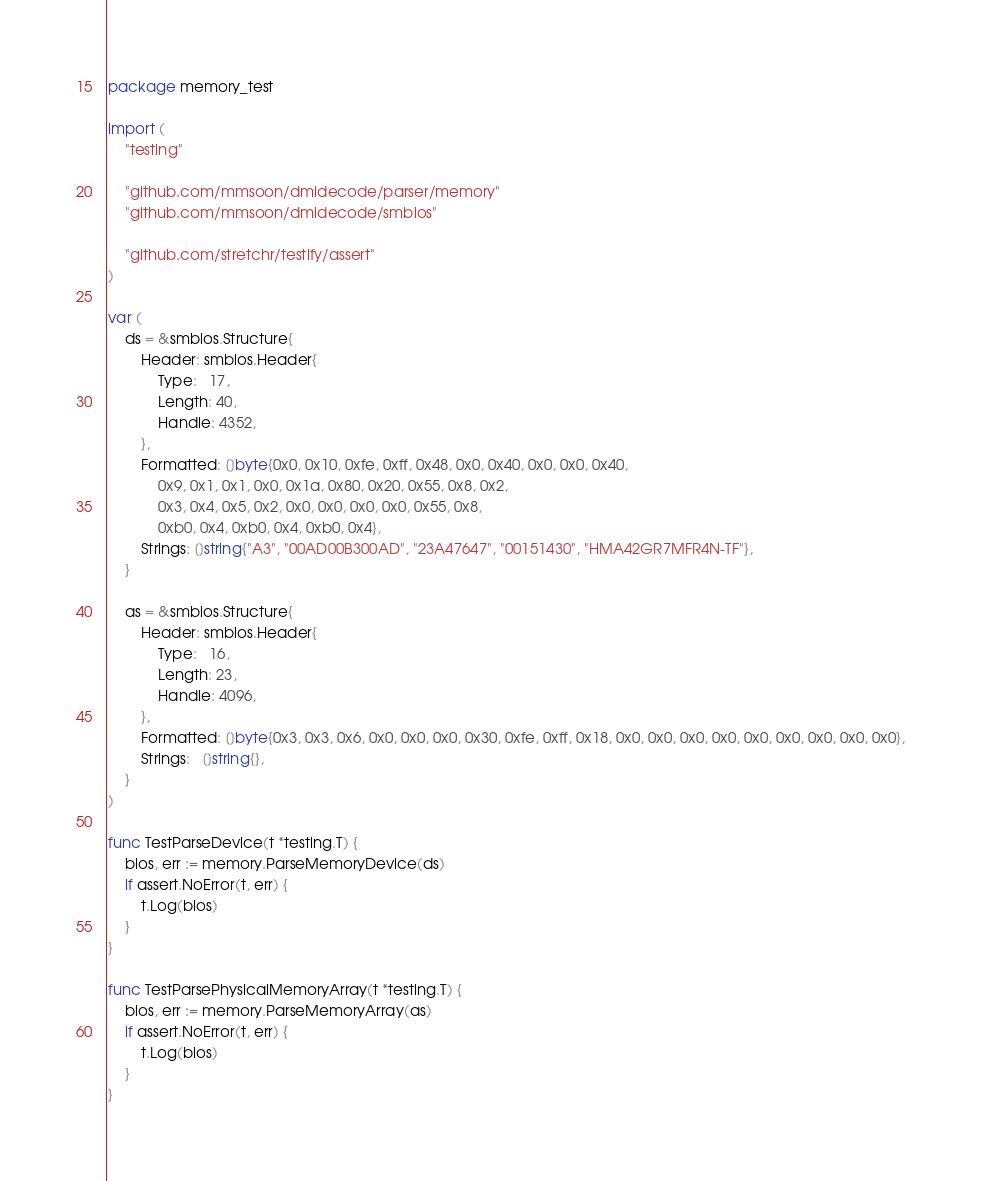Convert code to text. <code><loc_0><loc_0><loc_500><loc_500><_Go_>package memory_test

import (
	"testing"

	"github.com/mmsoon/dmidecode/parser/memory"
	"github.com/mmsoon/dmidecode/smbios"

	"github.com/stretchr/testify/assert"
)

var (
	ds = &smbios.Structure{
		Header: smbios.Header{
			Type:   17,
			Length: 40,
			Handle: 4352,
		},
		Formatted: []byte{0x0, 0x10, 0xfe, 0xff, 0x48, 0x0, 0x40, 0x0, 0x0, 0x40,
			0x9, 0x1, 0x1, 0x0, 0x1a, 0x80, 0x20, 0x55, 0x8, 0x2,
			0x3, 0x4, 0x5, 0x2, 0x0, 0x0, 0x0, 0x0, 0x55, 0x8,
			0xb0, 0x4, 0xb0, 0x4, 0xb0, 0x4},
		Strings: []string{"A3", "00AD00B300AD", "23A47647", "00151430", "HMA42GR7MFR4N-TF"},
	}

	as = &smbios.Structure{
		Header: smbios.Header{
			Type:   16,
			Length: 23,
			Handle: 4096,
		},
		Formatted: []byte{0x3, 0x3, 0x6, 0x0, 0x0, 0x0, 0x30, 0xfe, 0xff, 0x18, 0x0, 0x0, 0x0, 0x0, 0x0, 0x0, 0x0, 0x0, 0x0},
		Strings:   []string{},
	}
)

func TestParseDevice(t *testing.T) {
	bios, err := memory.ParseMemoryDevice(ds)
	if assert.NoError(t, err) {
		t.Log(bios)
	}
}

func TestParsePhysicalMemoryArray(t *testing.T) {
	bios, err := memory.ParseMemoryArray(as)
	if assert.NoError(t, err) {
		t.Log(bios)
	}
}
</code> 